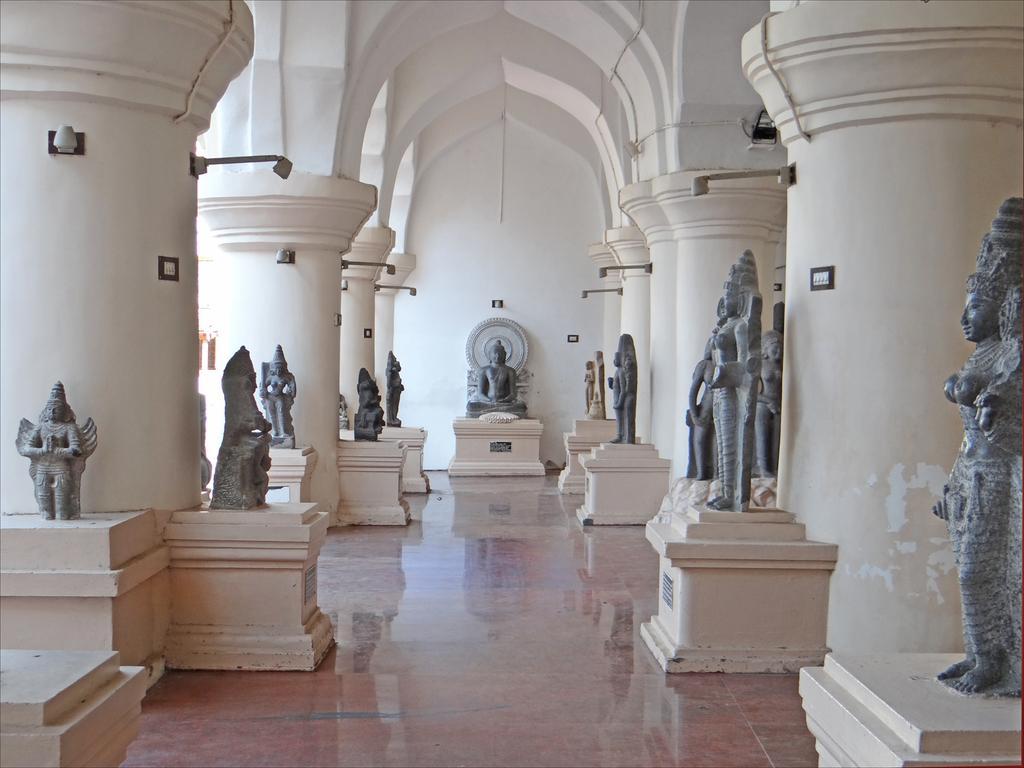In one or two sentences, can you explain what this image depicts? In this picture we can see the inside view of the corridor. In the front we can see some black statues, placed on the concrete tables. Above we can see the arch design pillars. 